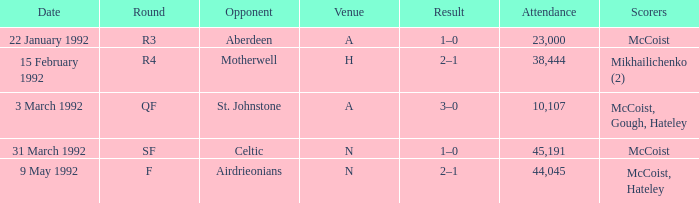In which venue was round F? N. 